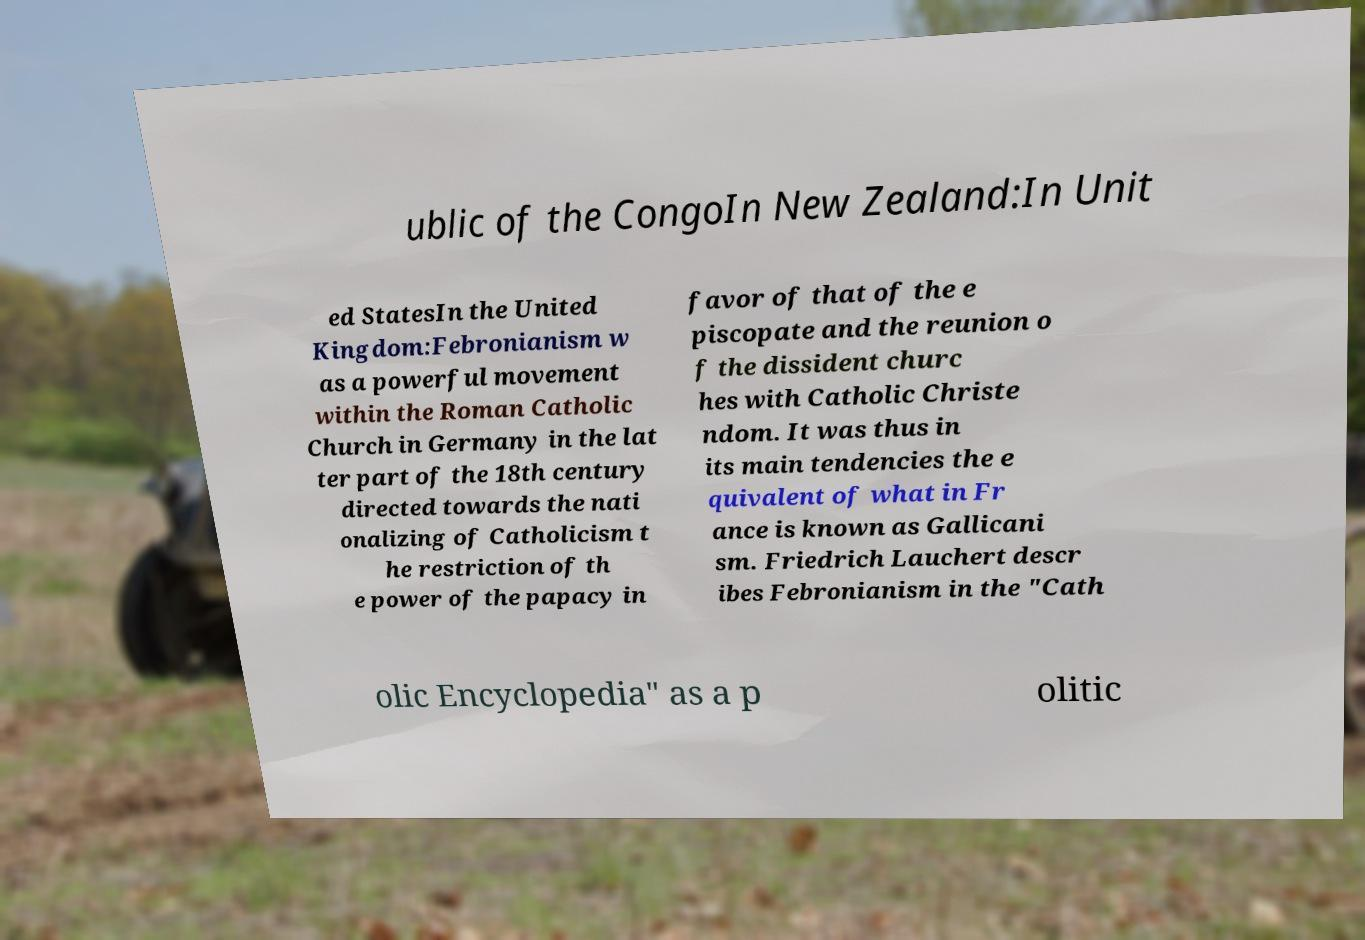Please read and relay the text visible in this image. What does it say? ublic of the CongoIn New Zealand:In Unit ed StatesIn the United Kingdom:Febronianism w as a powerful movement within the Roman Catholic Church in Germany in the lat ter part of the 18th century directed towards the nati onalizing of Catholicism t he restriction of th e power of the papacy in favor of that of the e piscopate and the reunion o f the dissident churc hes with Catholic Christe ndom. It was thus in its main tendencies the e quivalent of what in Fr ance is known as Gallicani sm. Friedrich Lauchert descr ibes Febronianism in the "Cath olic Encyclopedia" as a p olitic 